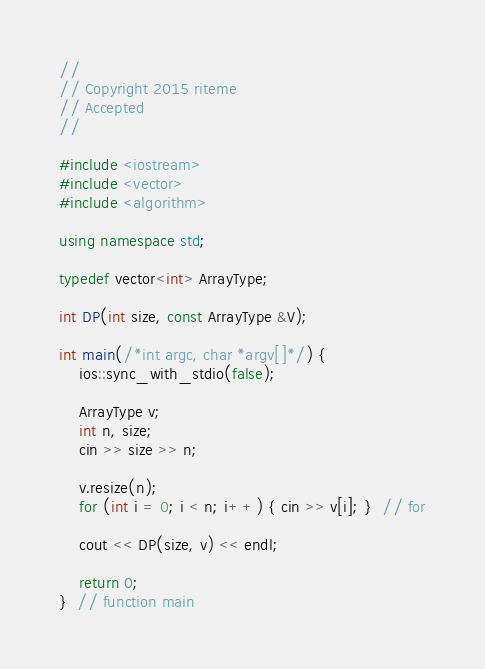<code> <loc_0><loc_0><loc_500><loc_500><_C++_>//
// Copyright 2015 riteme
// Accepted
//

#include <iostream>
#include <vector>
#include <algorithm>

using namespace std;

typedef vector<int> ArrayType;

int DP(int size, const ArrayType &V);

int main(/*int argc, char *argv[]*/) {
    ios::sync_with_stdio(false);

    ArrayType v;
    int n, size;
    cin >> size >> n;

    v.resize(n);
    for (int i = 0; i < n; i++) { cin >> v[i]; }  // for

    cout << DP(size, v) << endl;

    return 0;
}  // function main
</code> 